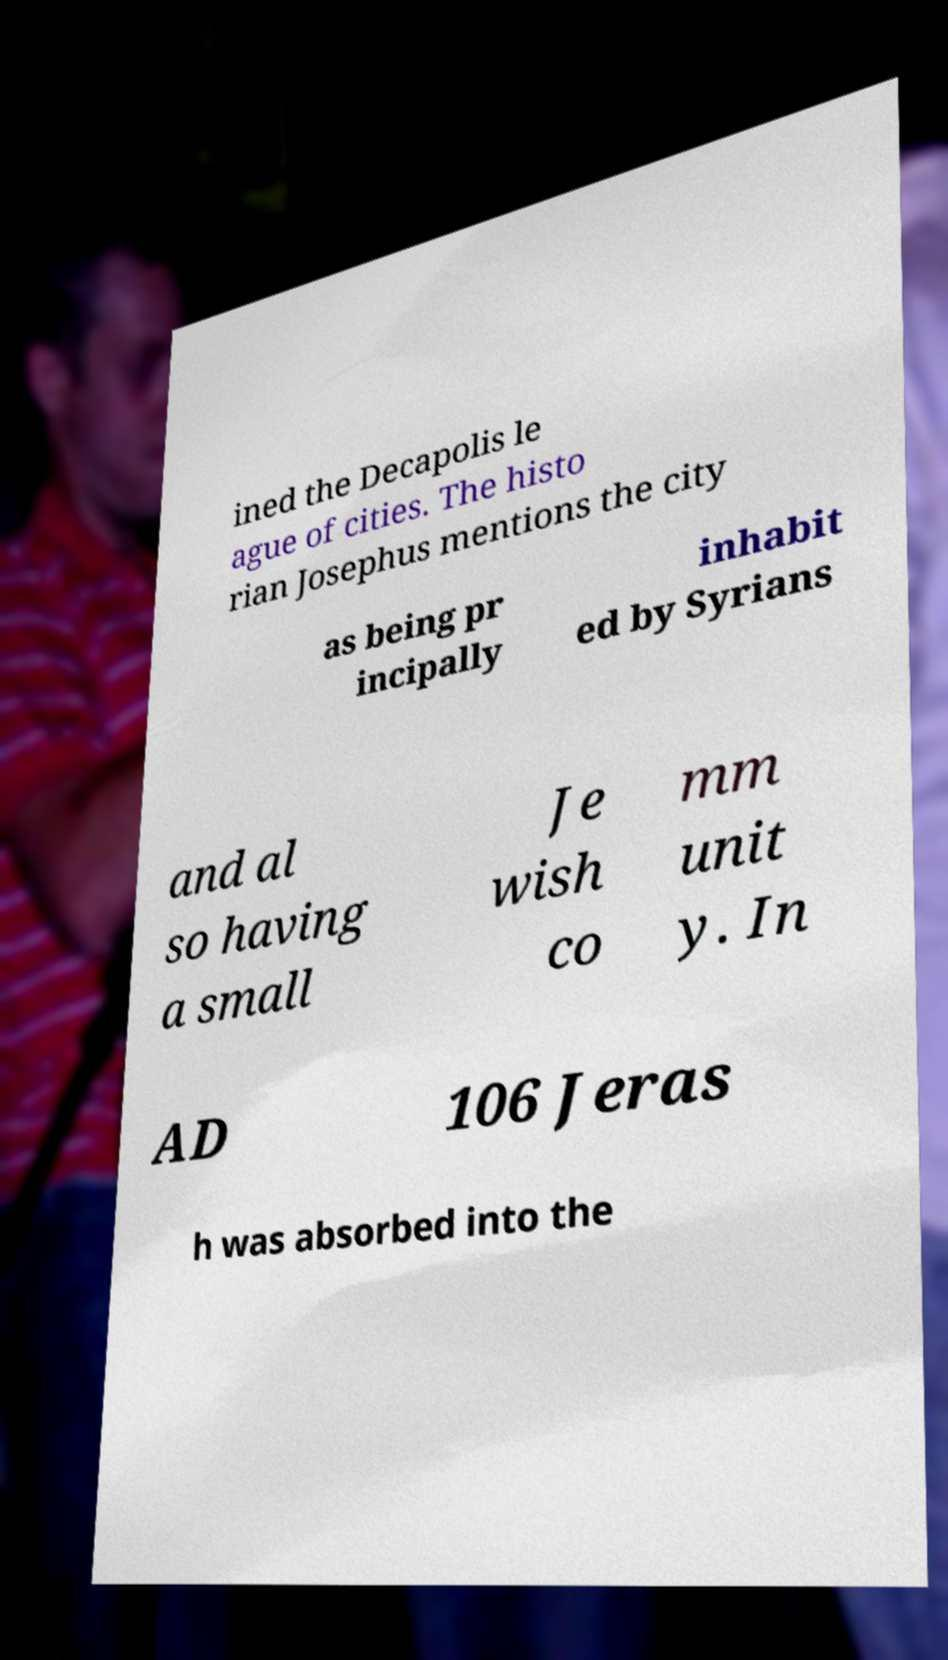There's text embedded in this image that I need extracted. Can you transcribe it verbatim? ined the Decapolis le ague of cities. The histo rian Josephus mentions the city as being pr incipally inhabit ed by Syrians and al so having a small Je wish co mm unit y. In AD 106 Jeras h was absorbed into the 